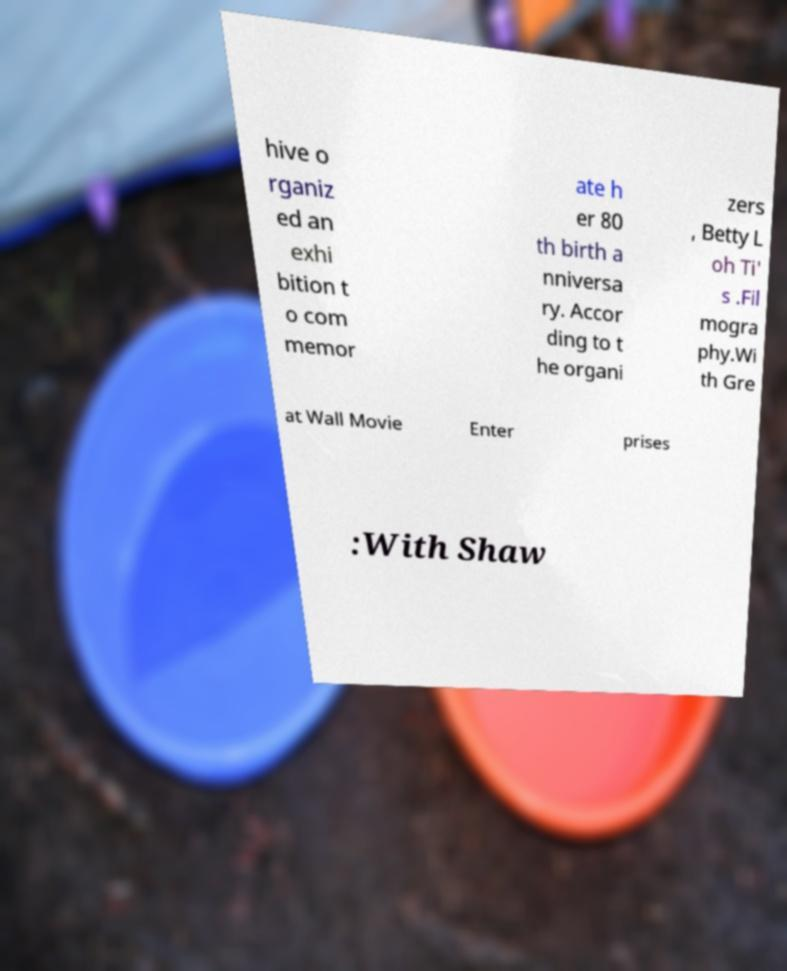Could you extract and type out the text from this image? hive o rganiz ed an exhi bition t o com memor ate h er 80 th birth a nniversa ry. Accor ding to t he organi zers , Betty L oh Ti' s .Fil mogra phy.Wi th Gre at Wall Movie Enter prises :With Shaw 